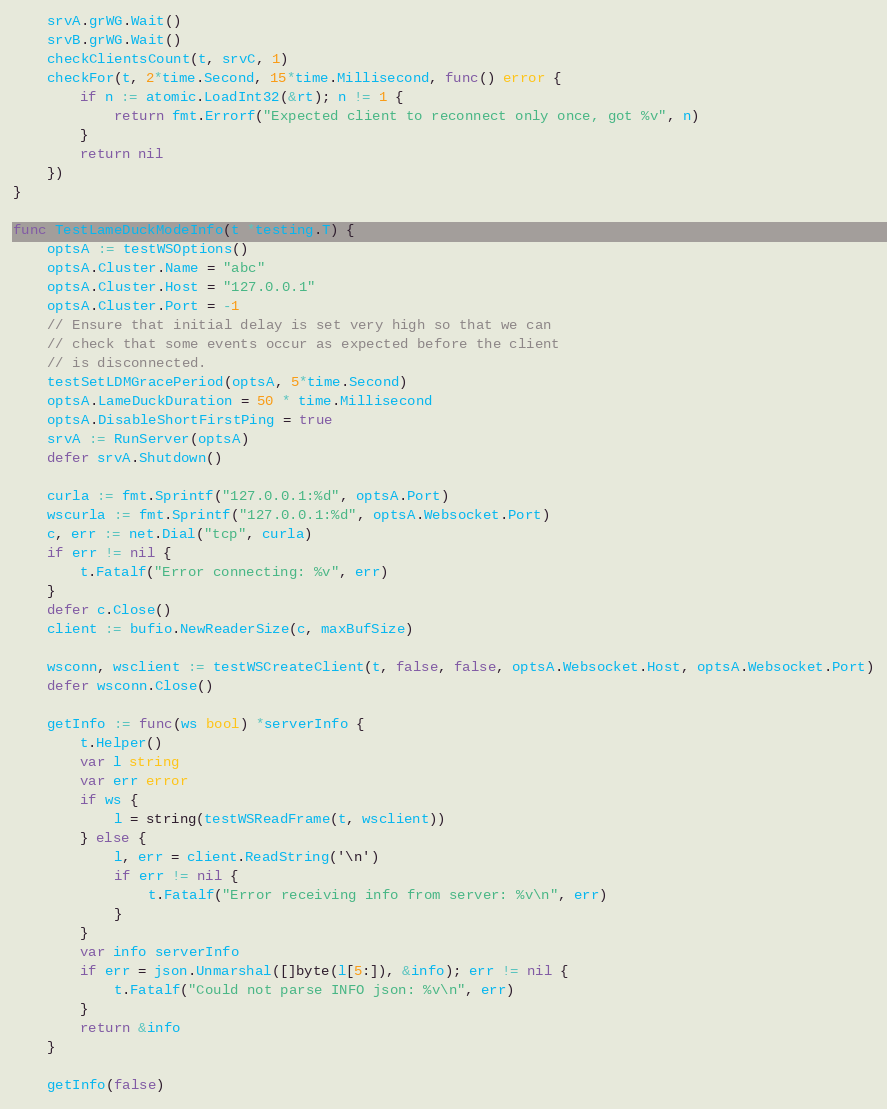<code> <loc_0><loc_0><loc_500><loc_500><_Go_>	srvA.grWG.Wait()
	srvB.grWG.Wait()
	checkClientsCount(t, srvC, 1)
	checkFor(t, 2*time.Second, 15*time.Millisecond, func() error {
		if n := atomic.LoadInt32(&rt); n != 1 {
			return fmt.Errorf("Expected client to reconnect only once, got %v", n)
		}
		return nil
	})
}

func TestLameDuckModeInfo(t *testing.T) {
	optsA := testWSOptions()
	optsA.Cluster.Name = "abc"
	optsA.Cluster.Host = "127.0.0.1"
	optsA.Cluster.Port = -1
	// Ensure that initial delay is set very high so that we can
	// check that some events occur as expected before the client
	// is disconnected.
	testSetLDMGracePeriod(optsA, 5*time.Second)
	optsA.LameDuckDuration = 50 * time.Millisecond
	optsA.DisableShortFirstPing = true
	srvA := RunServer(optsA)
	defer srvA.Shutdown()

	curla := fmt.Sprintf("127.0.0.1:%d", optsA.Port)
	wscurla := fmt.Sprintf("127.0.0.1:%d", optsA.Websocket.Port)
	c, err := net.Dial("tcp", curla)
	if err != nil {
		t.Fatalf("Error connecting: %v", err)
	}
	defer c.Close()
	client := bufio.NewReaderSize(c, maxBufSize)

	wsconn, wsclient := testWSCreateClient(t, false, false, optsA.Websocket.Host, optsA.Websocket.Port)
	defer wsconn.Close()

	getInfo := func(ws bool) *serverInfo {
		t.Helper()
		var l string
		var err error
		if ws {
			l = string(testWSReadFrame(t, wsclient))
		} else {
			l, err = client.ReadString('\n')
			if err != nil {
				t.Fatalf("Error receiving info from server: %v\n", err)
			}
		}
		var info serverInfo
		if err = json.Unmarshal([]byte(l[5:]), &info); err != nil {
			t.Fatalf("Could not parse INFO json: %v\n", err)
		}
		return &info
	}

	getInfo(false)</code> 